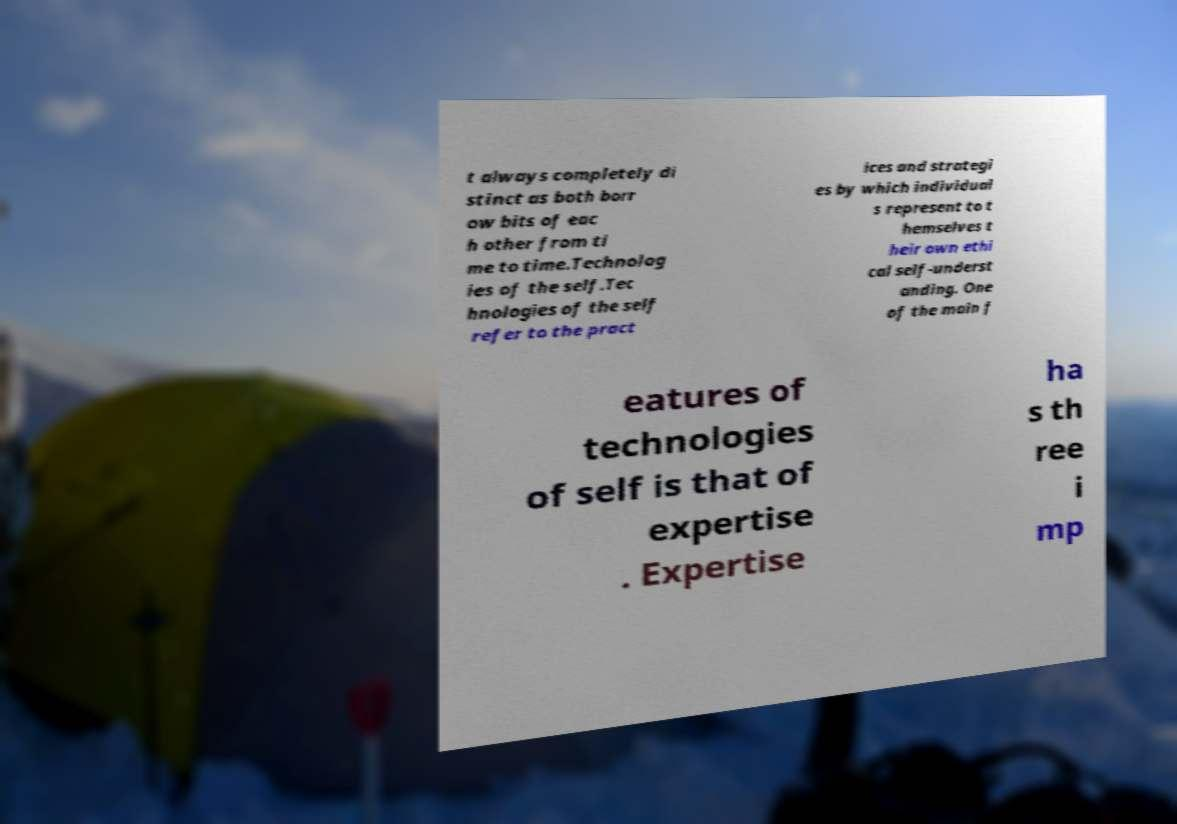There's text embedded in this image that I need extracted. Can you transcribe it verbatim? t always completely di stinct as both borr ow bits of eac h other from ti me to time.Technolog ies of the self.Tec hnologies of the self refer to the pract ices and strategi es by which individual s represent to t hemselves t heir own ethi cal self-underst anding. One of the main f eatures of technologies of self is that of expertise . Expertise ha s th ree i mp 